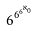<formula> <loc_0><loc_0><loc_500><loc_500>6 ^ { 6 ^ { 6 ^ { \aleph _ { 0 } } } }</formula> 